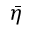<formula> <loc_0><loc_0><loc_500><loc_500>\bar { \eta }</formula> 